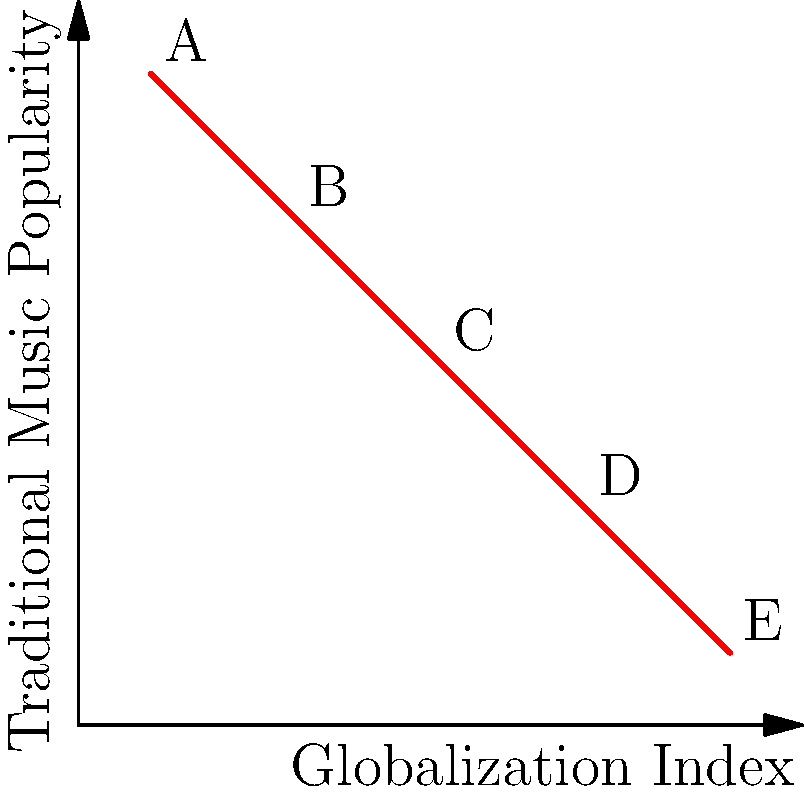The scatter plot shows the relationship between a Globalization Index and Traditional Music Popularity for five indigenous communities (A-E). What type of correlation does this data suggest, and how might this inform your documentary about the impact of globalization on indigenous music? To determine the correlation and its implications, let's analyze the scatter plot step-by-step:

1. Observe the overall trend: As we move from left to right (increasing Globalization Index), the points generally move downward (decreasing Traditional Music Popularity).

2. Identify the correlation type: This pattern indicates a negative or inverse correlation between the Globalization Index and Traditional Music Popularity.

3. Assess the strength: The points form a fairly straight line, suggesting a strong correlation.

4. Calculate the correlation coefficient: While we can't calculate the exact value without more data, visually, it appears to be close to -1, indicating a strong negative correlation.

5. Interpret the data:
   a. Community A: Low globalization, high traditional music popularity
   b. Community E: High globalization, low traditional music popularity
   c. Communities B, C, and D: Show gradual transitions between these extremes

6. Implications for the documentary:
   a. This data suggests that as communities become more globalized, the popularity of their traditional music decreases.
   b. It could indicate that globalization may be leading to a loss of cultural musical traditions.
   c. The documentary could explore the factors causing this correlation, such as:
      - Increased exposure to global music trends
      - Changes in lifestyle and cultural practices
      - Economic pressures affecting traditional musicians

7. Considerations for the documentary:
   a. Investigate exceptions to this trend, if any
   b. Explore efforts to preserve traditional music in highly globalized communities
   c. Examine the potential for fusion music that combines traditional and global elements

The strong negative correlation provides a clear narrative thread for the documentary, highlighting the tension between globalization and the preservation of indigenous musical traditions.
Answer: Strong negative correlation; globalization associated with decreased traditional music popularity. 